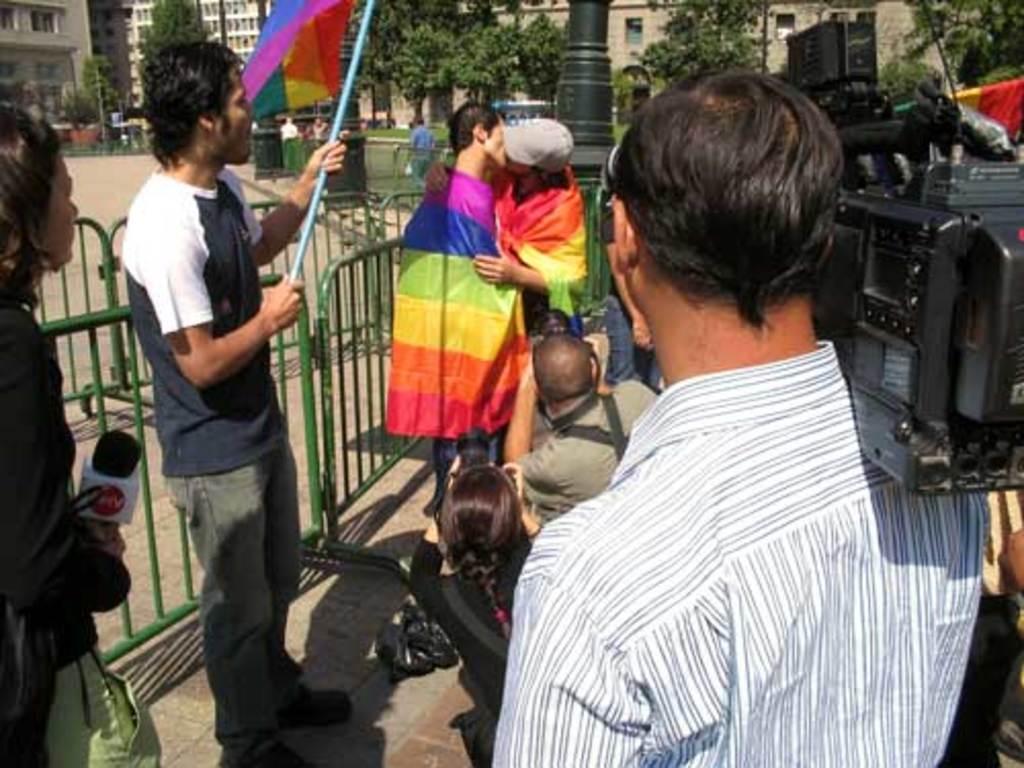How would you summarize this image in a sentence or two? In this image there are two guys kissing each other on the floor. Beside them there is fence. On the right side there is a man taking the pictures with the camera. On the left side there is a person standing on the floor by holding the mic. Beside her there is a man standing by holding the flag which has different colours in it. In the background there are buildings and trees. At the bottom there are two persons taking the pictures with the camera. 